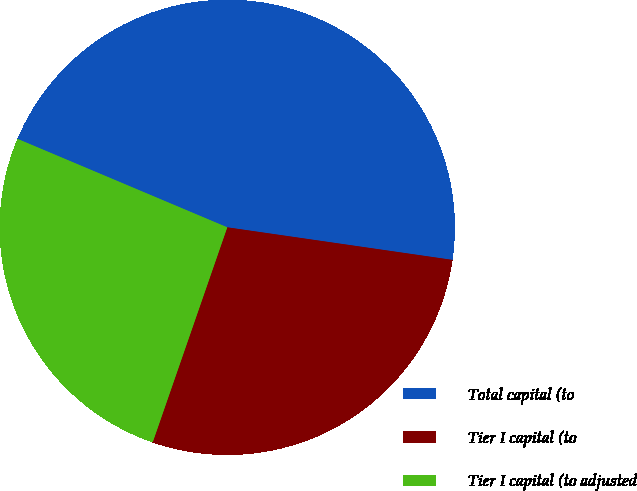<chart> <loc_0><loc_0><loc_500><loc_500><pie_chart><fcel>Total capital (to<fcel>Tier I capital (to<fcel>Tier I capital (to adjusted<nl><fcel>45.94%<fcel>28.03%<fcel>26.04%<nl></chart> 